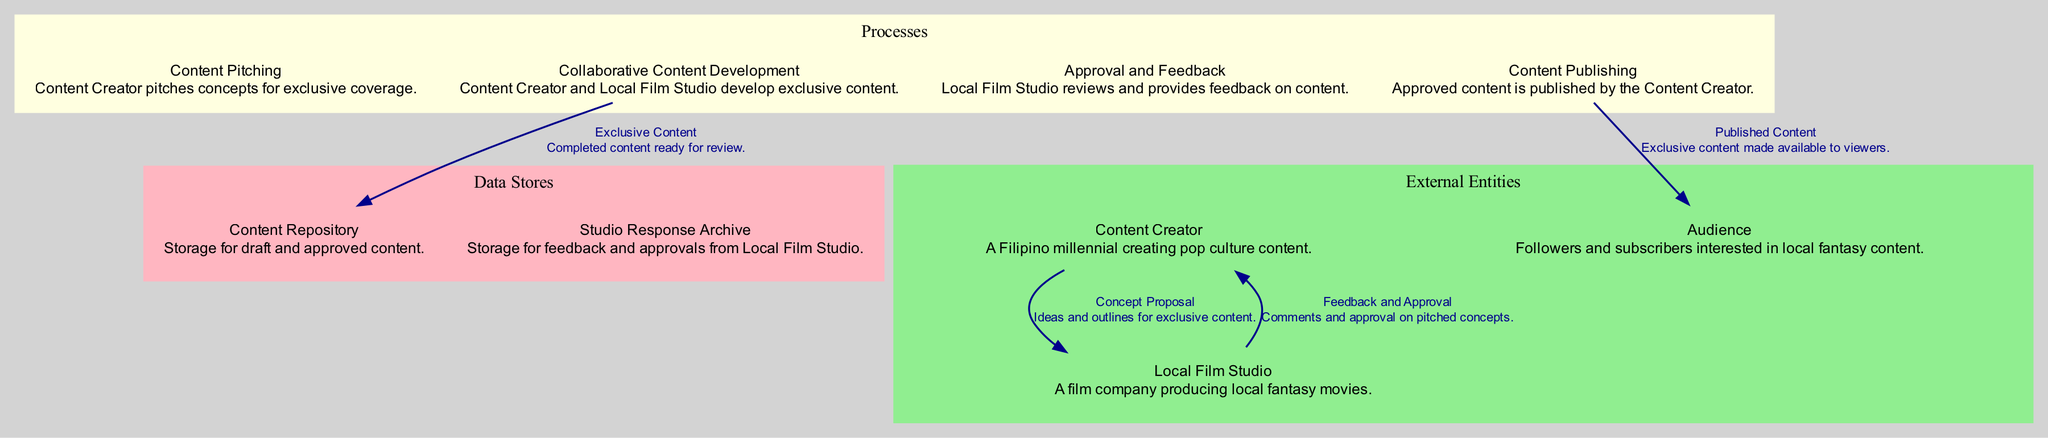What is the number of external entities in the diagram? The diagram shows three external entities: Content Creator, Local Film Studio, and Audience. By counting these entities, we find that there are three of them.
Answer: three Which process is responsible for publishing the content? The Content Publishing process is specifically described as the step where approved content is published by the Content Creator. This indicates that it is the process responsible for publishing content.
Answer: Content Publishing What data flow originates from the Content Creator? The data flow called Concept Proposal originates from the Content Creator and is directed to the Local Film Studio. This flow involves ideas and outlines for exclusive content pitched by the Content Creator.
Answer: Concept Proposal What is stored in the Content Repository? The Content Repository is described as the storage for draft and approved content produced in the collaboration process. Therefore, it holds the completed exclusive content that is ready for review.
Answer: draft and approved content How does the Local Film Studio provide feedback to the Content Creator? The Local Film Studio provides feedback to the Content Creator through the flow labeled Feedback and Approval. This flow indicates that comments and approval regarding pitched concepts are communicated back to the Content Creator.
Answer: Feedback and Approval What type of data store is the Studio Response Archive? The Studio Response Archive is classified as a data store in the diagram, specifically described as storage for feedback and approvals from the Local Film Studio. Its purpose is to save this type of information within the collaboration process.
Answer: data store Which external entity is the audience for the published content? The Audience is the external entity targeted as the viewers interested in local fantasy content, making them the intended recipients of the Published Content. This relationship illustrates who consumes the final product of the creation process.
Answer: Audience How many processes are involved in the collaboration process? There are four processes identified in the diagram: Content Pitching, Collaborative Content Development, Approval and Feedback, and Content Publishing. By counting these processes, we can conclude that there are four in total.
Answer: four What is the role of the Collaborative Content Development process? The role of the Collaborative Content Development process is to facilitate the joint effort between the Content Creator and the Local Film Studio in developing exclusive content. This process is crucial for producing the content to be pitched and published later.
Answer: develop exclusive content 